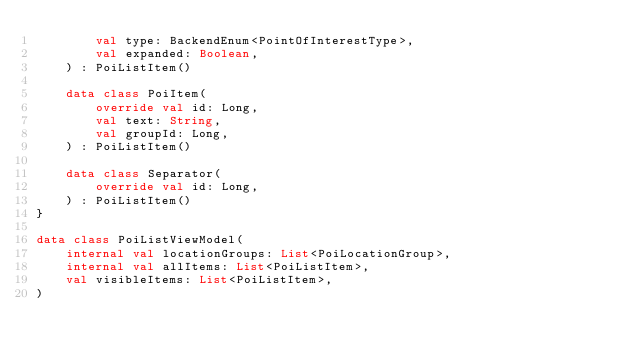<code> <loc_0><loc_0><loc_500><loc_500><_Kotlin_>        val type: BackendEnum<PointOfInterestType>,
        val expanded: Boolean,
    ) : PoiListItem()

    data class PoiItem(
        override val id: Long,
        val text: String,
        val groupId: Long,
    ) : PoiListItem()

    data class Separator(
        override val id: Long,
    ) : PoiListItem()
}

data class PoiListViewModel(
    internal val locationGroups: List<PoiLocationGroup>,
    internal val allItems: List<PoiListItem>,
    val visibleItems: List<PoiListItem>,
)
</code> 